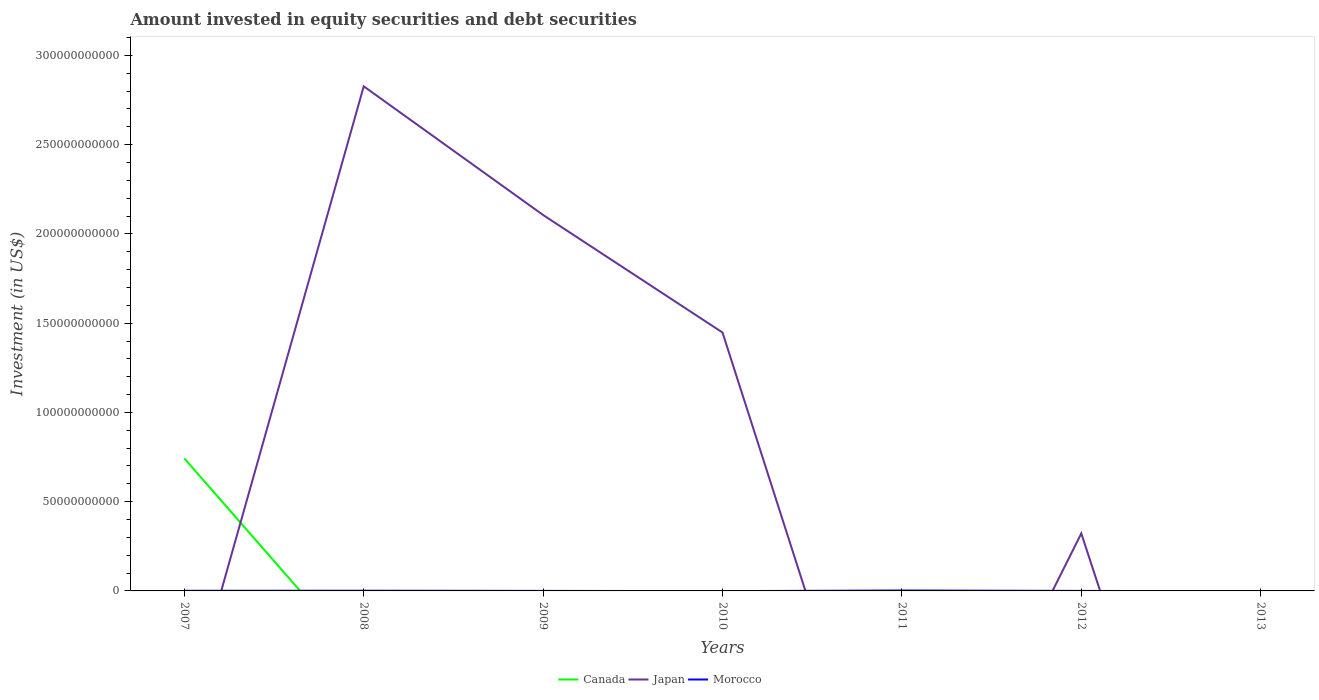Does the line corresponding to Canada intersect with the line corresponding to Morocco?
Your answer should be very brief. Yes. Is the number of lines equal to the number of legend labels?
Your answer should be very brief. No. What is the total amount invested in equity securities and debt securities in Japan in the graph?
Provide a succinct answer. 6.58e+1. What is the difference between the highest and the second highest amount invested in equity securities and debt securities in Morocco?
Your answer should be very brief. 2.34e+08. Is the amount invested in equity securities and debt securities in Morocco strictly greater than the amount invested in equity securities and debt securities in Canada over the years?
Offer a terse response. No. How many lines are there?
Offer a very short reply. 3. How many years are there in the graph?
Your answer should be compact. 7. Does the graph contain any zero values?
Ensure brevity in your answer.  Yes. Does the graph contain grids?
Make the answer very short. No. What is the title of the graph?
Provide a short and direct response. Amount invested in equity securities and debt securities. What is the label or title of the X-axis?
Make the answer very short. Years. What is the label or title of the Y-axis?
Provide a short and direct response. Investment (in US$). What is the Investment (in US$) of Canada in 2007?
Your answer should be very brief. 7.42e+1. What is the Investment (in US$) of Japan in 2007?
Provide a succinct answer. 0. What is the Investment (in US$) in Morocco in 2007?
Make the answer very short. 8.02e+07. What is the Investment (in US$) of Japan in 2008?
Ensure brevity in your answer.  2.83e+11. What is the Investment (in US$) in Morocco in 2008?
Your answer should be very brief. 1.09e+08. What is the Investment (in US$) of Canada in 2009?
Keep it short and to the point. 0. What is the Investment (in US$) in Japan in 2009?
Your answer should be very brief. 2.11e+11. What is the Investment (in US$) in Morocco in 2009?
Provide a succinct answer. 1.66e+07. What is the Investment (in US$) of Canada in 2010?
Ensure brevity in your answer.  0. What is the Investment (in US$) in Japan in 2010?
Your response must be concise. 1.45e+11. What is the Investment (in US$) of Morocco in 2010?
Your answer should be compact. 0. What is the Investment (in US$) of Japan in 2011?
Provide a succinct answer. 0. What is the Investment (in US$) of Morocco in 2011?
Your response must be concise. 2.34e+08. What is the Investment (in US$) in Canada in 2012?
Provide a short and direct response. 0. What is the Investment (in US$) of Japan in 2012?
Offer a terse response. 3.22e+1. What is the Investment (in US$) in Morocco in 2012?
Your answer should be compact. 5.72e+06. What is the Investment (in US$) in Canada in 2013?
Offer a very short reply. 0. What is the Investment (in US$) of Japan in 2013?
Your answer should be compact. 0. What is the Investment (in US$) of Morocco in 2013?
Your answer should be very brief. 0. Across all years, what is the maximum Investment (in US$) in Canada?
Your response must be concise. 7.42e+1. Across all years, what is the maximum Investment (in US$) of Japan?
Keep it short and to the point. 2.83e+11. Across all years, what is the maximum Investment (in US$) in Morocco?
Provide a succinct answer. 2.34e+08. Across all years, what is the minimum Investment (in US$) of Canada?
Give a very brief answer. 0. Across all years, what is the minimum Investment (in US$) in Japan?
Keep it short and to the point. 0. What is the total Investment (in US$) in Canada in the graph?
Give a very brief answer. 7.42e+1. What is the total Investment (in US$) of Japan in the graph?
Ensure brevity in your answer.  6.70e+11. What is the total Investment (in US$) of Morocco in the graph?
Your response must be concise. 4.45e+08. What is the difference between the Investment (in US$) of Morocco in 2007 and that in 2008?
Your response must be concise. -2.90e+07. What is the difference between the Investment (in US$) in Morocco in 2007 and that in 2009?
Your response must be concise. 6.36e+07. What is the difference between the Investment (in US$) in Morocco in 2007 and that in 2011?
Ensure brevity in your answer.  -1.53e+08. What is the difference between the Investment (in US$) in Morocco in 2007 and that in 2012?
Your answer should be compact. 7.44e+07. What is the difference between the Investment (in US$) in Japan in 2008 and that in 2009?
Offer a very short reply. 7.21e+1. What is the difference between the Investment (in US$) of Morocco in 2008 and that in 2009?
Ensure brevity in your answer.  9.25e+07. What is the difference between the Investment (in US$) of Japan in 2008 and that in 2010?
Your answer should be very brief. 1.38e+11. What is the difference between the Investment (in US$) of Morocco in 2008 and that in 2011?
Your answer should be very brief. -1.24e+08. What is the difference between the Investment (in US$) in Japan in 2008 and that in 2012?
Your answer should be very brief. 2.50e+11. What is the difference between the Investment (in US$) of Morocco in 2008 and that in 2012?
Provide a succinct answer. 1.03e+08. What is the difference between the Investment (in US$) in Japan in 2009 and that in 2010?
Offer a very short reply. 6.58e+1. What is the difference between the Investment (in US$) of Morocco in 2009 and that in 2011?
Your answer should be very brief. -2.17e+08. What is the difference between the Investment (in US$) of Japan in 2009 and that in 2012?
Your response must be concise. 1.78e+11. What is the difference between the Investment (in US$) in Morocco in 2009 and that in 2012?
Ensure brevity in your answer.  1.09e+07. What is the difference between the Investment (in US$) of Japan in 2010 and that in 2012?
Make the answer very short. 1.13e+11. What is the difference between the Investment (in US$) of Morocco in 2011 and that in 2012?
Offer a very short reply. 2.28e+08. What is the difference between the Investment (in US$) in Canada in 2007 and the Investment (in US$) in Japan in 2008?
Your answer should be compact. -2.08e+11. What is the difference between the Investment (in US$) of Canada in 2007 and the Investment (in US$) of Morocco in 2008?
Provide a succinct answer. 7.41e+1. What is the difference between the Investment (in US$) in Canada in 2007 and the Investment (in US$) in Japan in 2009?
Your response must be concise. -1.36e+11. What is the difference between the Investment (in US$) of Canada in 2007 and the Investment (in US$) of Morocco in 2009?
Give a very brief answer. 7.42e+1. What is the difference between the Investment (in US$) of Canada in 2007 and the Investment (in US$) of Japan in 2010?
Ensure brevity in your answer.  -7.05e+1. What is the difference between the Investment (in US$) in Canada in 2007 and the Investment (in US$) in Morocco in 2011?
Keep it short and to the point. 7.40e+1. What is the difference between the Investment (in US$) of Canada in 2007 and the Investment (in US$) of Japan in 2012?
Your answer should be compact. 4.20e+1. What is the difference between the Investment (in US$) in Canada in 2007 and the Investment (in US$) in Morocco in 2012?
Your answer should be very brief. 7.42e+1. What is the difference between the Investment (in US$) of Japan in 2008 and the Investment (in US$) of Morocco in 2009?
Offer a very short reply. 2.83e+11. What is the difference between the Investment (in US$) of Japan in 2008 and the Investment (in US$) of Morocco in 2011?
Keep it short and to the point. 2.82e+11. What is the difference between the Investment (in US$) of Japan in 2008 and the Investment (in US$) of Morocco in 2012?
Your answer should be very brief. 2.83e+11. What is the difference between the Investment (in US$) in Japan in 2009 and the Investment (in US$) in Morocco in 2011?
Keep it short and to the point. 2.10e+11. What is the difference between the Investment (in US$) in Japan in 2009 and the Investment (in US$) in Morocco in 2012?
Make the answer very short. 2.11e+11. What is the difference between the Investment (in US$) of Japan in 2010 and the Investment (in US$) of Morocco in 2011?
Give a very brief answer. 1.45e+11. What is the difference between the Investment (in US$) in Japan in 2010 and the Investment (in US$) in Morocco in 2012?
Provide a succinct answer. 1.45e+11. What is the average Investment (in US$) of Canada per year?
Your answer should be compact. 1.06e+1. What is the average Investment (in US$) of Japan per year?
Make the answer very short. 9.58e+1. What is the average Investment (in US$) of Morocco per year?
Keep it short and to the point. 6.36e+07. In the year 2007, what is the difference between the Investment (in US$) of Canada and Investment (in US$) of Morocco?
Make the answer very short. 7.41e+1. In the year 2008, what is the difference between the Investment (in US$) in Japan and Investment (in US$) in Morocco?
Provide a succinct answer. 2.83e+11. In the year 2009, what is the difference between the Investment (in US$) in Japan and Investment (in US$) in Morocco?
Provide a short and direct response. 2.11e+11. In the year 2012, what is the difference between the Investment (in US$) of Japan and Investment (in US$) of Morocco?
Give a very brief answer. 3.22e+1. What is the ratio of the Investment (in US$) of Morocco in 2007 to that in 2008?
Your response must be concise. 0.73. What is the ratio of the Investment (in US$) in Morocco in 2007 to that in 2009?
Your answer should be compact. 4.83. What is the ratio of the Investment (in US$) in Morocco in 2007 to that in 2011?
Give a very brief answer. 0.34. What is the ratio of the Investment (in US$) in Morocco in 2007 to that in 2012?
Make the answer very short. 14. What is the ratio of the Investment (in US$) of Japan in 2008 to that in 2009?
Provide a short and direct response. 1.34. What is the ratio of the Investment (in US$) in Morocco in 2008 to that in 2009?
Offer a very short reply. 6.58. What is the ratio of the Investment (in US$) in Japan in 2008 to that in 2010?
Provide a short and direct response. 1.95. What is the ratio of the Investment (in US$) of Morocco in 2008 to that in 2011?
Provide a short and direct response. 0.47. What is the ratio of the Investment (in US$) of Japan in 2008 to that in 2012?
Ensure brevity in your answer.  8.78. What is the ratio of the Investment (in US$) in Morocco in 2008 to that in 2012?
Provide a short and direct response. 19.06. What is the ratio of the Investment (in US$) of Japan in 2009 to that in 2010?
Make the answer very short. 1.45. What is the ratio of the Investment (in US$) of Morocco in 2009 to that in 2011?
Keep it short and to the point. 0.07. What is the ratio of the Investment (in US$) of Japan in 2009 to that in 2012?
Keep it short and to the point. 6.54. What is the ratio of the Investment (in US$) in Morocco in 2009 to that in 2012?
Your response must be concise. 2.9. What is the ratio of the Investment (in US$) of Japan in 2010 to that in 2012?
Provide a short and direct response. 4.49. What is the ratio of the Investment (in US$) of Morocco in 2011 to that in 2012?
Offer a very short reply. 40.79. What is the difference between the highest and the second highest Investment (in US$) of Japan?
Give a very brief answer. 7.21e+1. What is the difference between the highest and the second highest Investment (in US$) of Morocco?
Keep it short and to the point. 1.24e+08. What is the difference between the highest and the lowest Investment (in US$) of Canada?
Your response must be concise. 7.42e+1. What is the difference between the highest and the lowest Investment (in US$) in Japan?
Give a very brief answer. 2.83e+11. What is the difference between the highest and the lowest Investment (in US$) of Morocco?
Your answer should be very brief. 2.34e+08. 